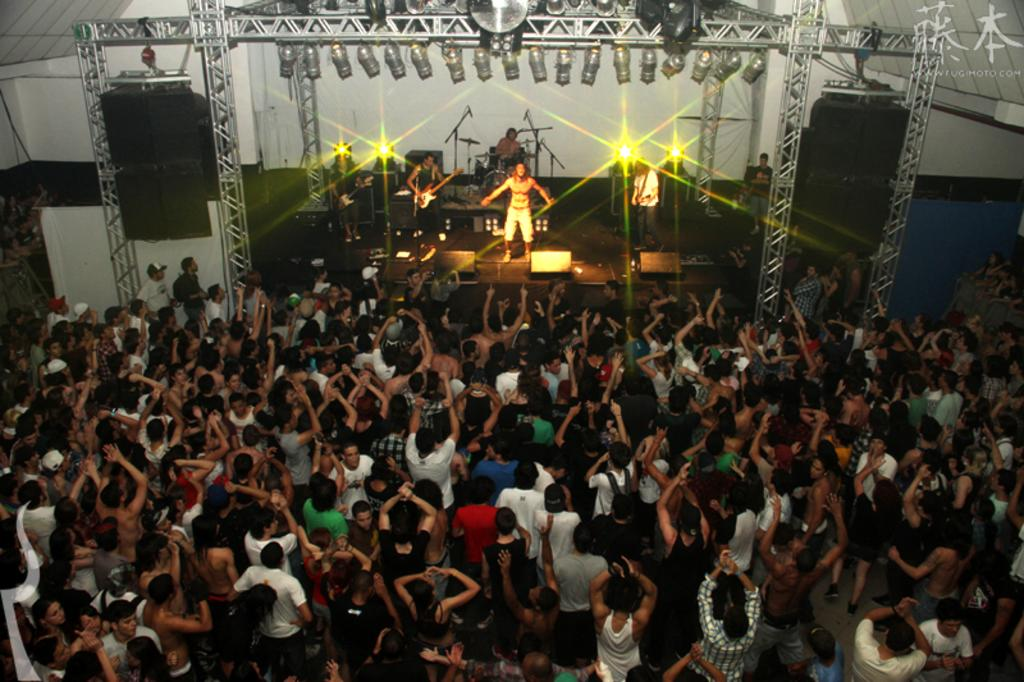What is the main subject of the image? The main subject of the image is a group of people standing in the center. What can be seen at the top of the image? At the top of the image, there are grills, lights, a band, a guitar, speakers, a dais, and a floor. What type of equipment is present at the top of the image? The equipment present at the top of the image includes grills, speakers, and a guitar. What is the purpose of the dais at the top of the image? The dais at the top of the image is likely a stage for the band to perform on. What type of vein is visible in the image? There are no veins visible in the image. Can you tell me how many cards are being held by the people in the image? There is no mention of cards in the image, so it cannot be determined if any are being held. 